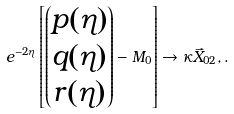Convert formula to latex. <formula><loc_0><loc_0><loc_500><loc_500>e ^ { - 2 \eta } \left [ \begin{pmatrix} p ( \eta ) \\ q ( \eta ) \\ r ( \eta ) \end{pmatrix} - M _ { 0 } \right ] \rightarrow \kappa \vec { X } _ { 0 2 } , .</formula> 